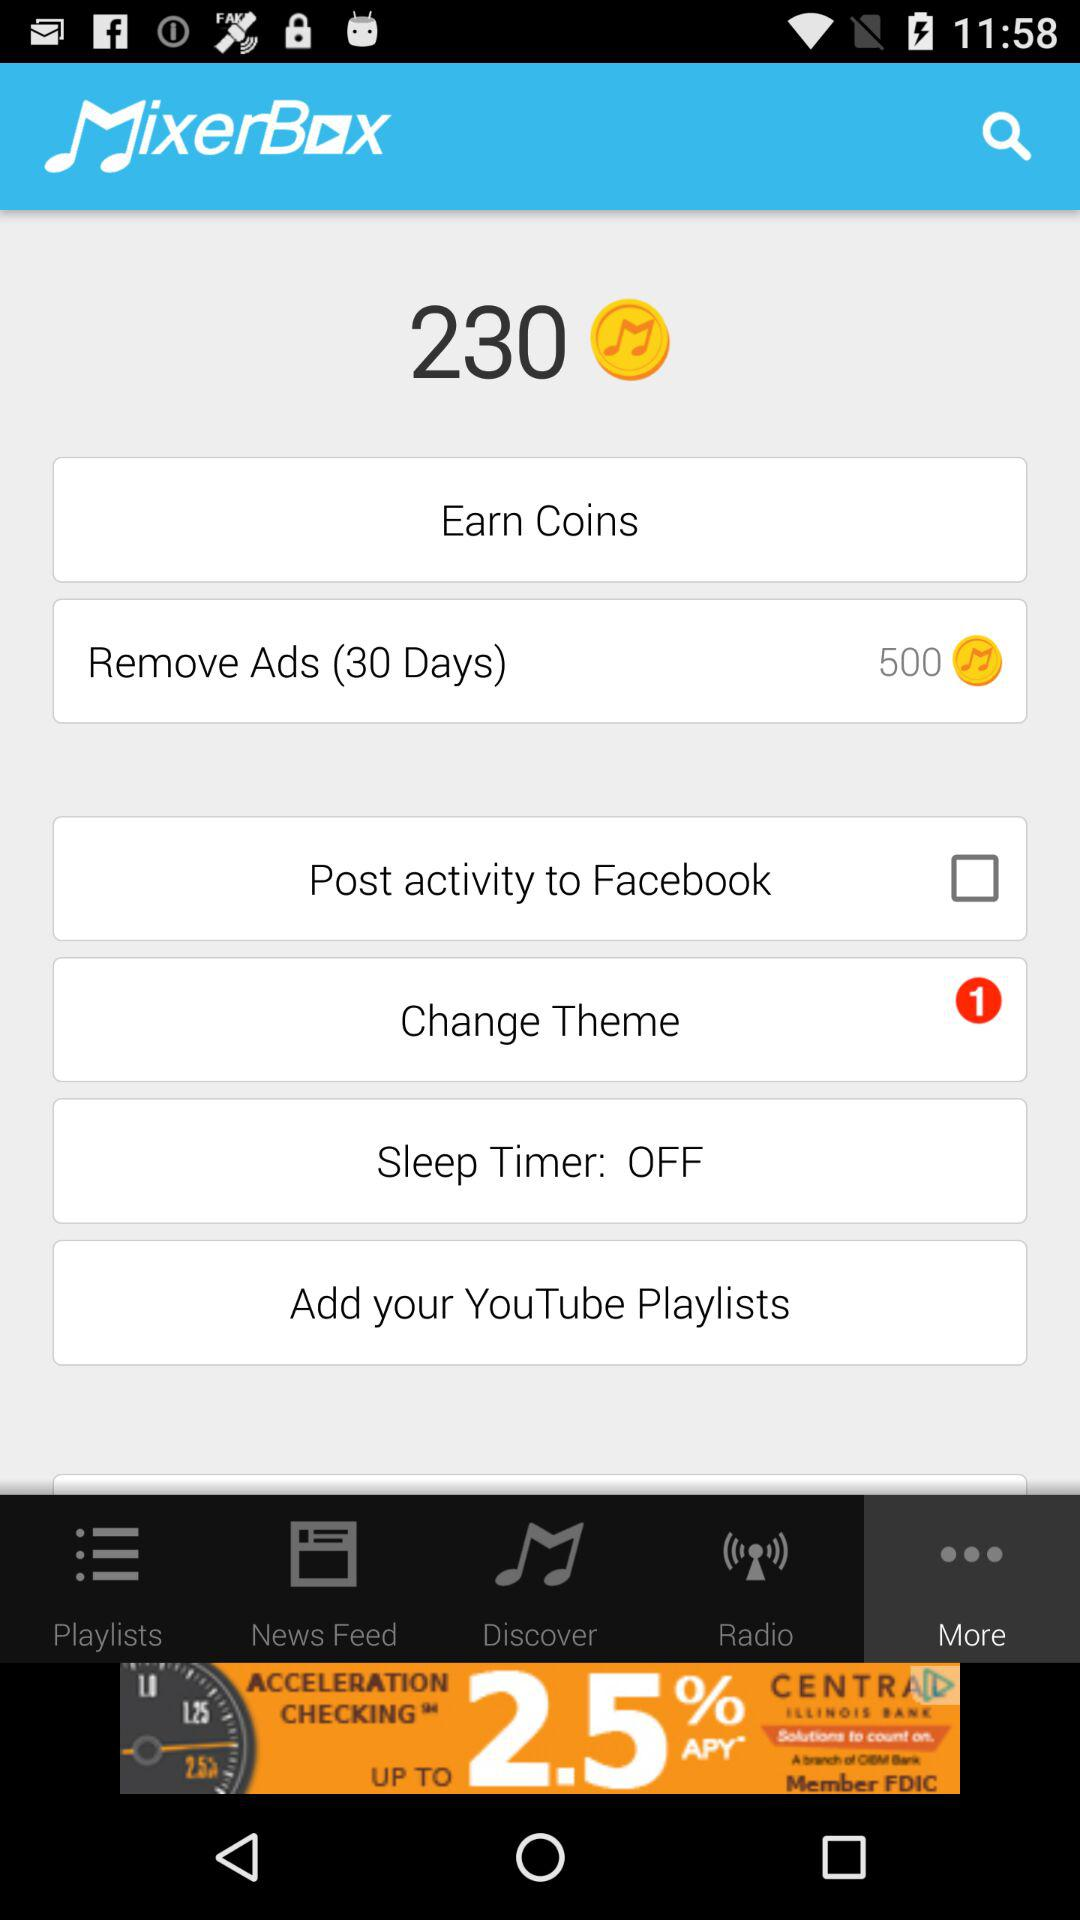What is the status of the "Sleep Timer"? The "Sleep Timer" is turned off. 